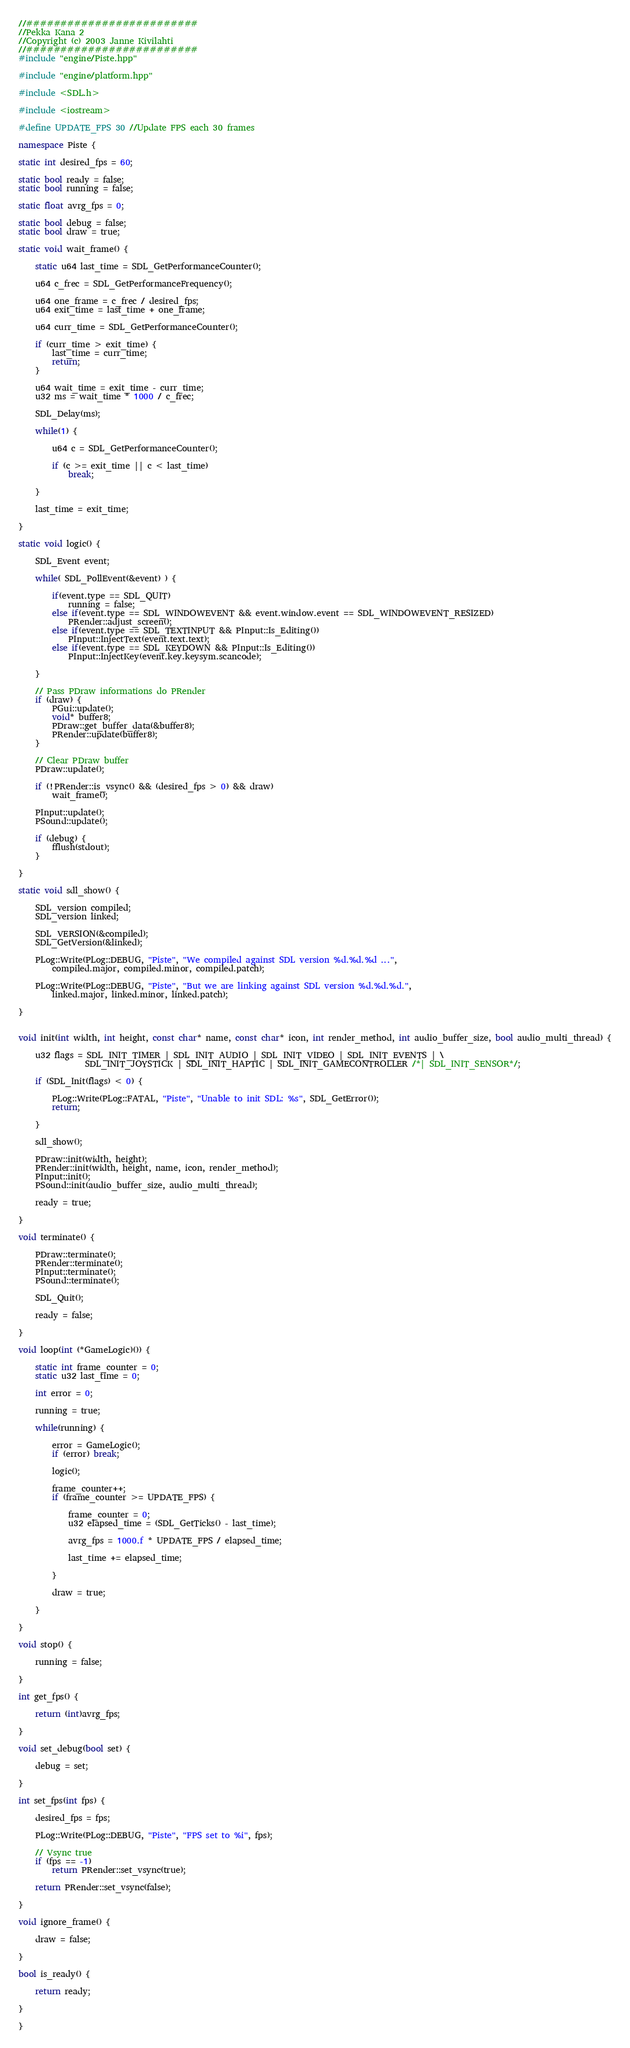Convert code to text. <code><loc_0><loc_0><loc_500><loc_500><_C++_>//#########################
//Pekka Kana 2
//Copyright (c) 2003 Janne Kivilahti
//#########################
#include "engine/Piste.hpp"

#include "engine/platform.hpp"

#include <SDL.h>

#include <iostream>

#define UPDATE_FPS 30 //Update FPS each 30 frames

namespace Piste {

static int desired_fps = 60;

static bool ready = false;
static bool running = false;

static float avrg_fps = 0;

static bool debug = false;
static bool draw = true;

static void wait_frame() {

	static u64 last_time = SDL_GetPerformanceCounter();

	u64 c_frec = SDL_GetPerformanceFrequency();

	u64 one_frame = c_frec / desired_fps;
	u64 exit_time = last_time + one_frame;
	
	u64 curr_time = SDL_GetPerformanceCounter();
	
	if (curr_time > exit_time) {
		last_time = curr_time;
		return;
	}
	
	u64 wait_time = exit_time - curr_time;
	u32 ms = wait_time * 1000 / c_frec;

	SDL_Delay(ms);

	while(1) {

		u64 c = SDL_GetPerformanceCounter();
		
		if (c >= exit_time || c < last_time)
			break;

	}

	last_time = exit_time;

}

static void logic() {
	
	SDL_Event event;

	while( SDL_PollEvent(&event) ) {
		
		if(event.type == SDL_QUIT)
			running = false;
		else if(event.type == SDL_WINDOWEVENT && event.window.event == SDL_WINDOWEVENT_RESIZED)
			PRender::adjust_screen();
		else if(event.type == SDL_TEXTINPUT && PInput::Is_Editing())
			PInput::InjectText(event.text.text);
		else if(event.type == SDL_KEYDOWN && PInput::Is_Editing())
			PInput::InjectKey(event.key.keysym.scancode);
		
	}

	// Pass PDraw informations do PRender
	if (draw) {
		PGui::update();
		void* buffer8;
		PDraw::get_buffer_data(&buffer8);
		PRender::update(buffer8);
	}

	// Clear PDraw buffer
	PDraw::update();

	if (!PRender::is_vsync() && (desired_fps > 0) && draw)
		wait_frame();

	PInput::update();
	PSound::update();
	
	if (debug) {
		fflush(stdout);
	}

}

static void sdl_show() {

	SDL_version compiled;
	SDL_version linked;

	SDL_VERSION(&compiled);
	SDL_GetVersion(&linked);
	
	PLog::Write(PLog::DEBUG, "Piste", "We compiled against SDL version %d.%d.%d ...",
		compiled.major, compiled.minor, compiled.patch);
	
	PLog::Write(PLog::DEBUG, "Piste", "But we are linking against SDL version %d.%d.%d.",
		linked.major, linked.minor, linked.patch);
	
}


void init(int width, int height, const char* name, const char* icon, int render_method, int audio_buffer_size, bool audio_multi_thread) {
	
	u32 flags = SDL_INIT_TIMER | SDL_INIT_AUDIO | SDL_INIT_VIDEO | SDL_INIT_EVENTS | \
                SDL_INIT_JOYSTICK | SDL_INIT_HAPTIC | SDL_INIT_GAMECONTROLLER /*| SDL_INIT_SENSOR*/;
	
	if (SDL_Init(flags) < 0) {

		PLog::Write(PLog::FATAL, "Piste", "Unable to init SDL: %s", SDL_GetError());
		return;
		
	}

	sdl_show();
	
	PDraw::init(width, height);
	PRender::init(width, height, name, icon, render_method);
	PInput::init();
	PSound::init(audio_buffer_size, audio_multi_thread);

	ready = true;

}

void terminate() {
	
	PDraw::terminate();
	PRender::terminate();
	PInput::terminate();
	PSound::terminate();

	SDL_Quit();

	ready = false;

}

void loop(int (*GameLogic)()) {
	
	static int frame_counter = 0;
	static u32 last_time = 0;
		
	int error = 0;

	running = true;

	while(running) {
		
		error = GameLogic();
		if (error) break;
		
		logic();

		frame_counter++;
		if (frame_counter >= UPDATE_FPS) {

			frame_counter = 0;
			u32 elapsed_time = (SDL_GetTicks() - last_time);

			avrg_fps = 1000.f * UPDATE_FPS / elapsed_time;	

			last_time += elapsed_time;
		
		}
		
		draw = true;
	
	}

}

void stop() {
	
	running = false;

}

int get_fps() {
	
	return (int)avrg_fps;

}

void set_debug(bool set) {

	debug = set;

}

int set_fps(int fps) {

	desired_fps = fps;

	PLog::Write(PLog::DEBUG, "Piste", "FPS set to %i", fps);
	
	// Vsync true
	if (fps == -1)
		return PRender::set_vsync(true);
	
	return PRender::set_vsync(false);

}

void ignore_frame() {

	draw = false;

}

bool is_ready() {

	return ready;

}

}
</code> 